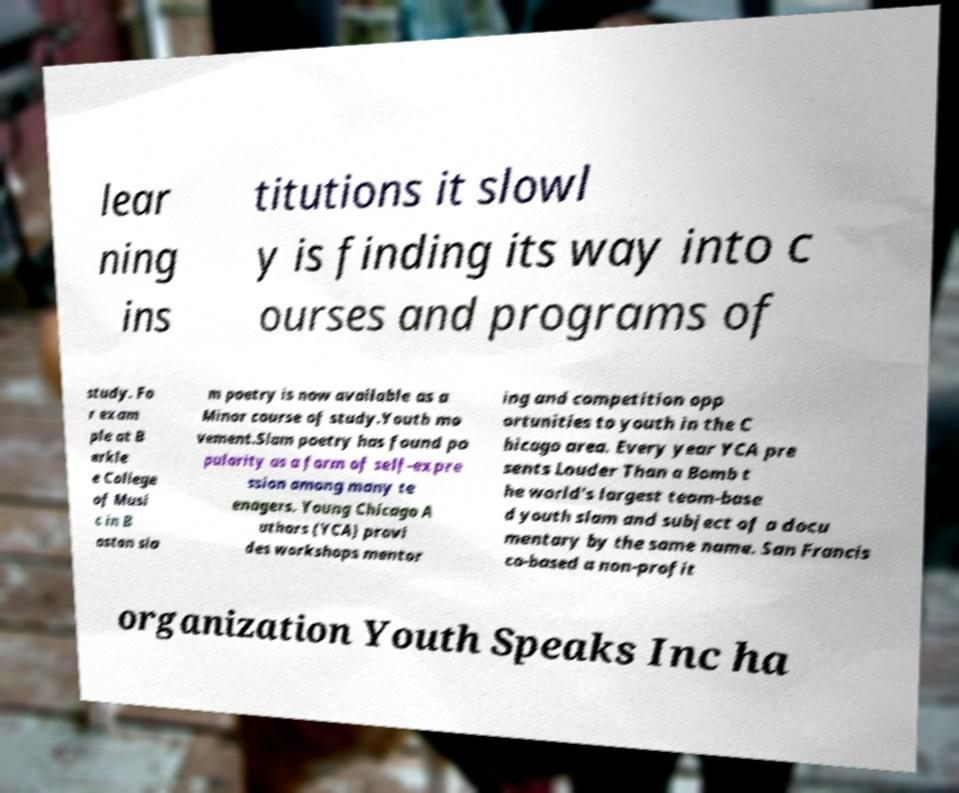What messages or text are displayed in this image? I need them in a readable, typed format. lear ning ins titutions it slowl y is finding its way into c ourses and programs of study. Fo r exam ple at B erkle e College of Musi c in B oston sla m poetry is now available as a Minor course of study.Youth mo vement.Slam poetry has found po pularity as a form of self-expre ssion among many te enagers. Young Chicago A uthors (YCA) provi des workshops mentor ing and competition opp ortunities to youth in the C hicago area. Every year YCA pre sents Louder Than a Bomb t he world's largest team-base d youth slam and subject of a docu mentary by the same name. San Francis co-based a non-profit organization Youth Speaks Inc ha 